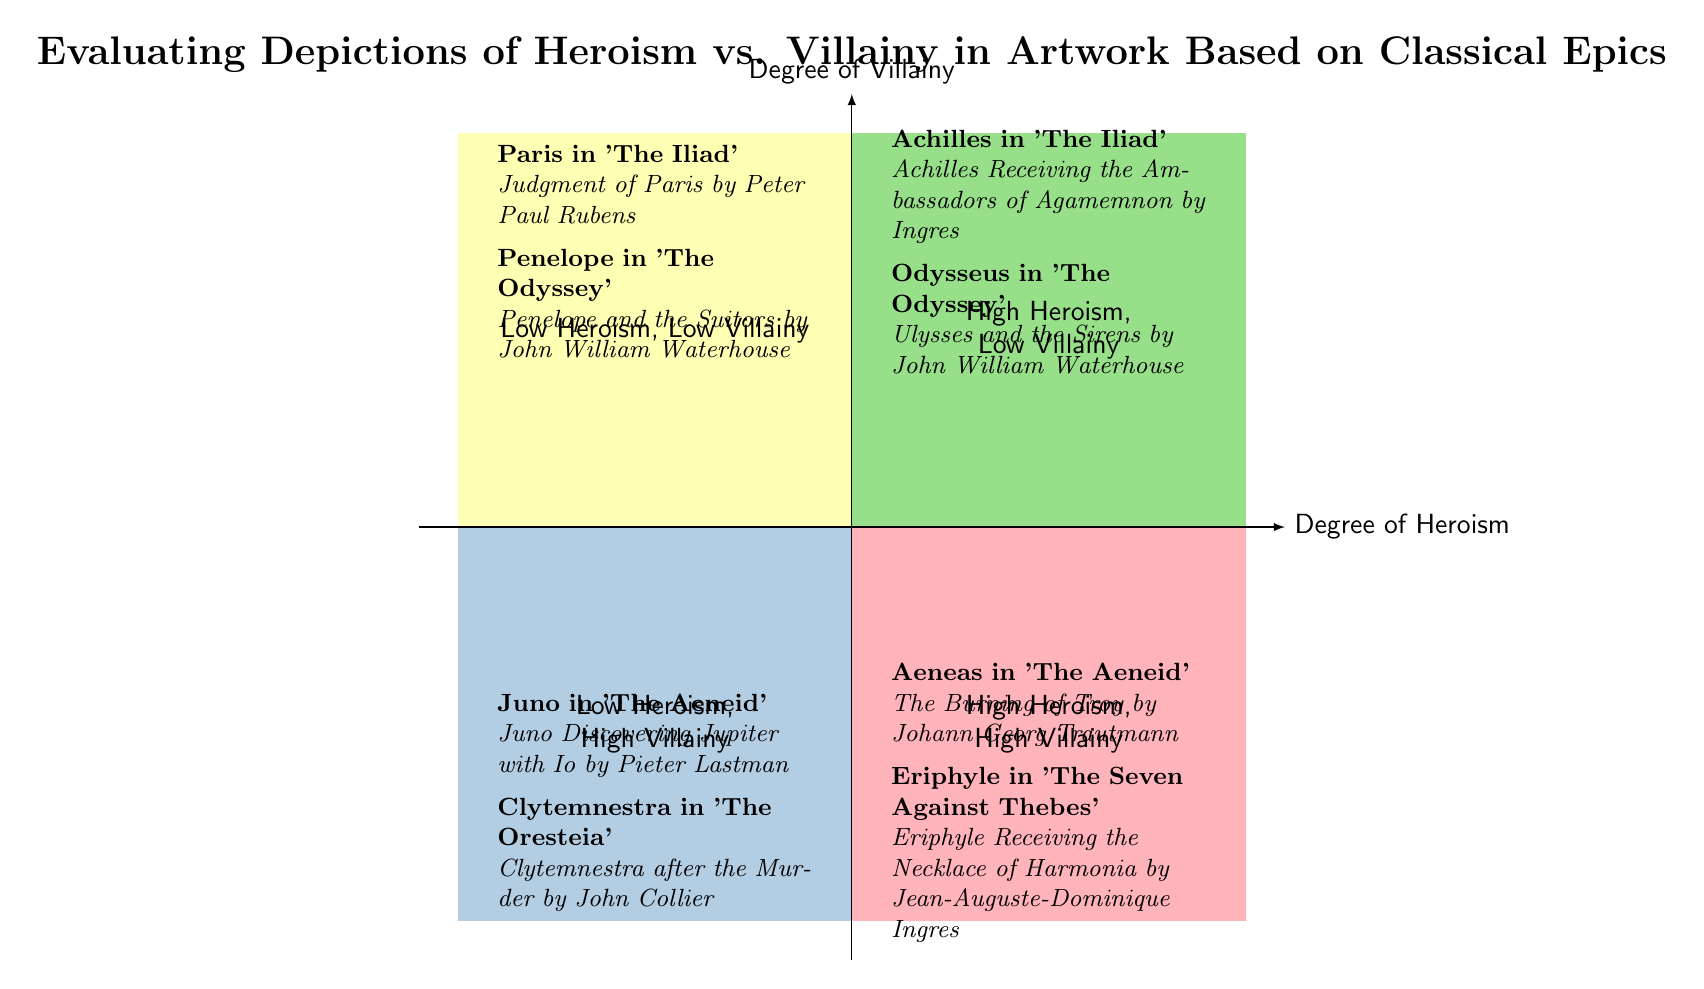What is the name of the artwork depicting Achilles in 'The Iliad'? The diagram lists "Achilles Receiving the Ambassadors of Agamemnon by Ingres" as the artwork associated with Achilles, located in the quadrant of High Heroism, Low Villainy.
Answer: Achilles Receiving the Ambassadors of Agamemnon by Ingres Which quadrant contains examples of High Heroism, High Villainy? The diagram indicates that the quadrant labeled "High Heroism, High Villainy" is on the bottom right side, where Aeneas in 'The Aeneid' and Eriphyle in 'The Seven Against Thebes' are located.
Answer: High Heroism, High Villainy How many artworks are associated with Penelope in ‘The Odyssey’? The diagram shows one artwork related to Penelope, which is "Penelope and the Suitors by John William Waterhouse," positioned in the Low Heroism, Low Villainy quadrant.
Answer: 1 Why is Juno classified as Low Heroism, High Villainy? Juno is depicted in the quadrant labeled Low Heroism, High Villainy due to her significant antagonistic role in 'The Aeneid,' as shown by the artwork "Juno Discovering Jupiter with Io by Pieter Lastman" reflecting her villainous traits.
Answer: Low Heroism, High Villainy What is the total number of characters represented in the High Heroism, Low Villainy quadrant? In this quadrant, there are two characters represented: Achilles and Odysseus, each associated with one artwork, making a total of two characters.
Answer: 2 Which character from 'The Iliad' appears in the Low Heroism, Low Villainy quadrant? The diagram states that Paris from 'The Iliad' is featured in the Low Heroism, Low Villainy quadrant with the artwork "Judgment of Paris by Peter Paul Rubens."
Answer: Paris What artworks depict high villainy alongside high heroism? The artworks representing high villainy alongside high heroism are "The Burning of Troy by Johann Georg Trautmann" for Aeneas and "Eriphyle Receiving the Necklace of Harmonia by Jean-Auguste-Dominique Ingres" for Eriphyle, both located in the High Heroism, High Villainy quadrant.
Answer: The Burning of Troy; Eriphyle Receiving the Necklace of Harmonia How are the quadrants organized based on heroism and villainy? The quadrants are arranged with degree of heroism on the x-axis (left to right) and degree of villainy on the y-axis (bottom to top), creating four distinct regions for analysis based on varying levels of both traits.
Answer: Organized by degree of heroism and villainy Who is depicted alongside Juno in the Low Heroism, High Villainy quadrant? The diagram notes that Clytemnestra appears alongside Juno in the Low Heroism, High Villainy quadrant, with her associated artwork being "Clytemnestra after the Murder by John Collier."
Answer: Clytemnestra 